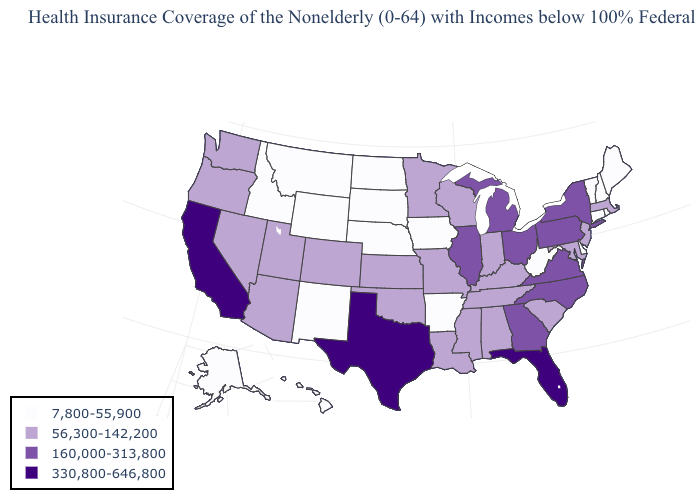What is the value of Delaware?
Concise answer only. 7,800-55,900. Name the states that have a value in the range 56,300-142,200?
Concise answer only. Alabama, Arizona, Colorado, Indiana, Kansas, Kentucky, Louisiana, Maryland, Massachusetts, Minnesota, Mississippi, Missouri, Nevada, New Jersey, Oklahoma, Oregon, South Carolina, Tennessee, Utah, Washington, Wisconsin. Name the states that have a value in the range 7,800-55,900?
Keep it brief. Alaska, Arkansas, Connecticut, Delaware, Hawaii, Idaho, Iowa, Maine, Montana, Nebraska, New Hampshire, New Mexico, North Dakota, Rhode Island, South Dakota, Vermont, West Virginia, Wyoming. What is the lowest value in states that border Minnesota?
Short answer required. 7,800-55,900. Does the first symbol in the legend represent the smallest category?
Give a very brief answer. Yes. Does Georgia have a higher value than Kansas?
Short answer required. Yes. What is the value of Florida?
Write a very short answer. 330,800-646,800. What is the value of Rhode Island?
Quick response, please. 7,800-55,900. Name the states that have a value in the range 330,800-646,800?
Write a very short answer. California, Florida, Texas. Does Hawaii have the lowest value in the West?
Answer briefly. Yes. What is the value of Utah?
Write a very short answer. 56,300-142,200. Does North Dakota have a lower value than Hawaii?
Concise answer only. No. How many symbols are there in the legend?
Give a very brief answer. 4. Is the legend a continuous bar?
Short answer required. No. Name the states that have a value in the range 7,800-55,900?
Give a very brief answer. Alaska, Arkansas, Connecticut, Delaware, Hawaii, Idaho, Iowa, Maine, Montana, Nebraska, New Hampshire, New Mexico, North Dakota, Rhode Island, South Dakota, Vermont, West Virginia, Wyoming. 